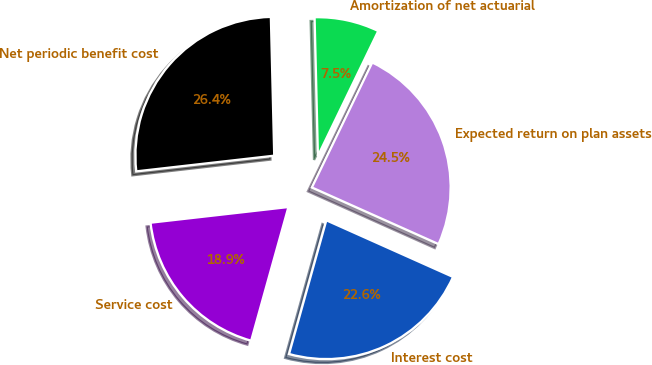Convert chart. <chart><loc_0><loc_0><loc_500><loc_500><pie_chart><fcel>Service cost<fcel>Interest cost<fcel>Expected return on plan assets<fcel>Amortization of net actuarial<fcel>Net periodic benefit cost<nl><fcel>18.87%<fcel>22.64%<fcel>24.53%<fcel>7.55%<fcel>26.42%<nl></chart> 